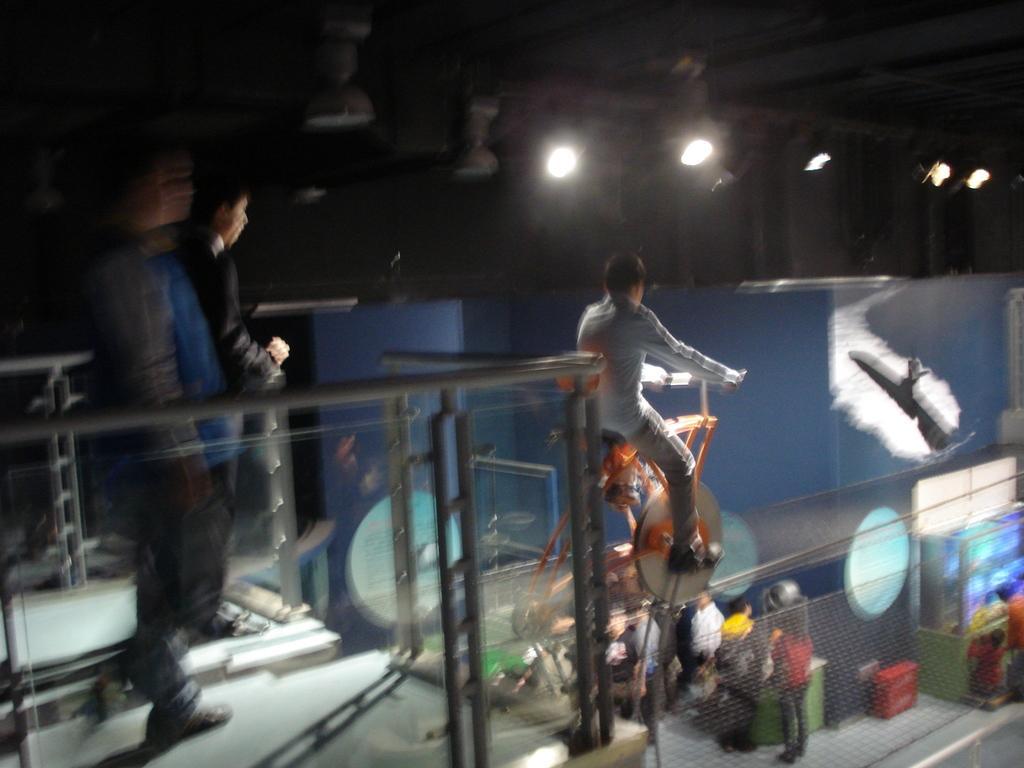Please provide a concise description of this image. In this picture we can see there are two people standing and a person is riding a vehicle on the rope. On the path there is a fence and some people are standing and behind the people there is a wall and at the top there are lights. 